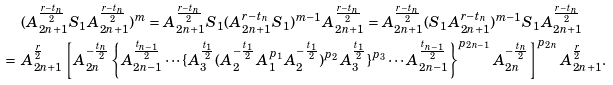Convert formula to latex. <formula><loc_0><loc_0><loc_500><loc_500>& \ ( A _ { 2 n + 1 } ^ { \frac { r - t _ { n } } { 2 } } S _ { 1 } A _ { 2 n + 1 } ^ { \frac { r - t _ { n } } { 2 } } ) ^ { m } = A _ { 2 n + 1 } ^ { { \frac { r - t _ { n } } { 2 } } } S _ { 1 } ( A _ { 2 n + 1 } ^ { r - t _ { n } } S _ { 1 } ) ^ { m - 1 } A _ { 2 n + 1 } ^ { { \frac { r - t _ { n } } { 2 } } } = A _ { 2 n + 1 } ^ { { \frac { r - t _ { n } } { 2 } } } ( S _ { 1 } A _ { 2 n + 1 } ^ { r - t _ { n } } ) ^ { m - 1 } S _ { 1 } A _ { 2 n + 1 } ^ { { \frac { r - t _ { n } } { 2 } } } \\ = & \ A ^ { \frac { r } { 2 } } _ { 2 n + 1 } \left [ A ^ { - { \frac { t _ { n } } { 2 } } } _ { 2 n } \left \{ A ^ { \frac { t _ { n - 1 } } { 2 } } _ { 2 n - 1 } \cdots \{ A ^ { \frac { t _ { 1 } } { 2 } } _ { 3 } ( A ^ { - { \frac { t _ { 1 } } { 2 } } } _ { 2 } A ^ { p _ { 1 } } _ { 1 } A ^ { - { \frac { t _ { 1 } } { 2 } } } _ { 2 } ) ^ { p _ { 2 } } A ^ { \frac { t _ { 1 } } { 2 } } _ { 3 } \} ^ { p _ { 3 } } \cdots A ^ { \frac { t _ { n - 1 } } { 2 } } _ { 2 n - 1 } \right \} ^ { p _ { 2 n - 1 } } A ^ { - { \frac { t _ { n } } { 2 } } } _ { 2 n } \right ] ^ { p _ { 2 n } } A ^ { \frac { r } { 2 } } _ { 2 n + 1 } .</formula> 